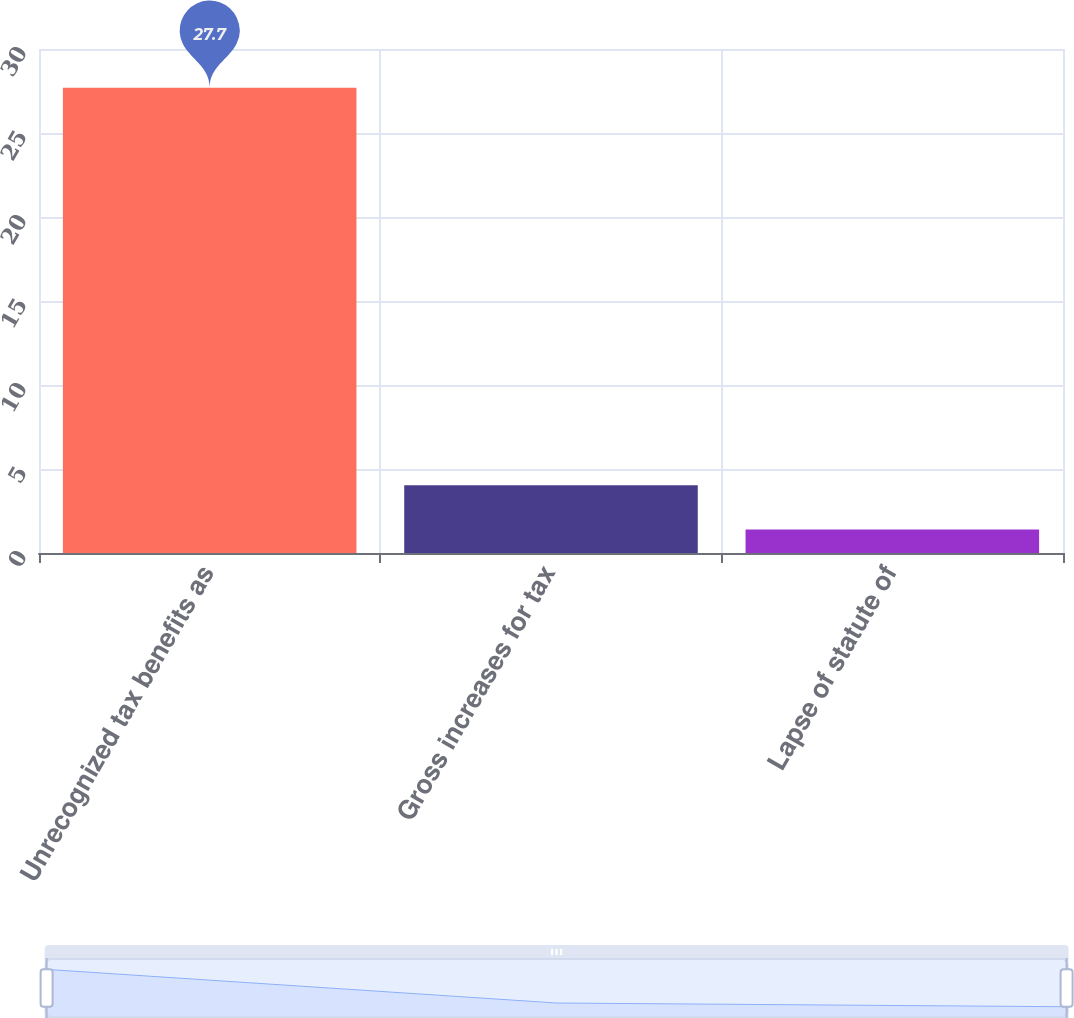Convert chart. <chart><loc_0><loc_0><loc_500><loc_500><bar_chart><fcel>Unrecognized tax benefits as<fcel>Gross increases for tax<fcel>Lapse of statute of<nl><fcel>27.7<fcel>4.03<fcel>1.4<nl></chart> 